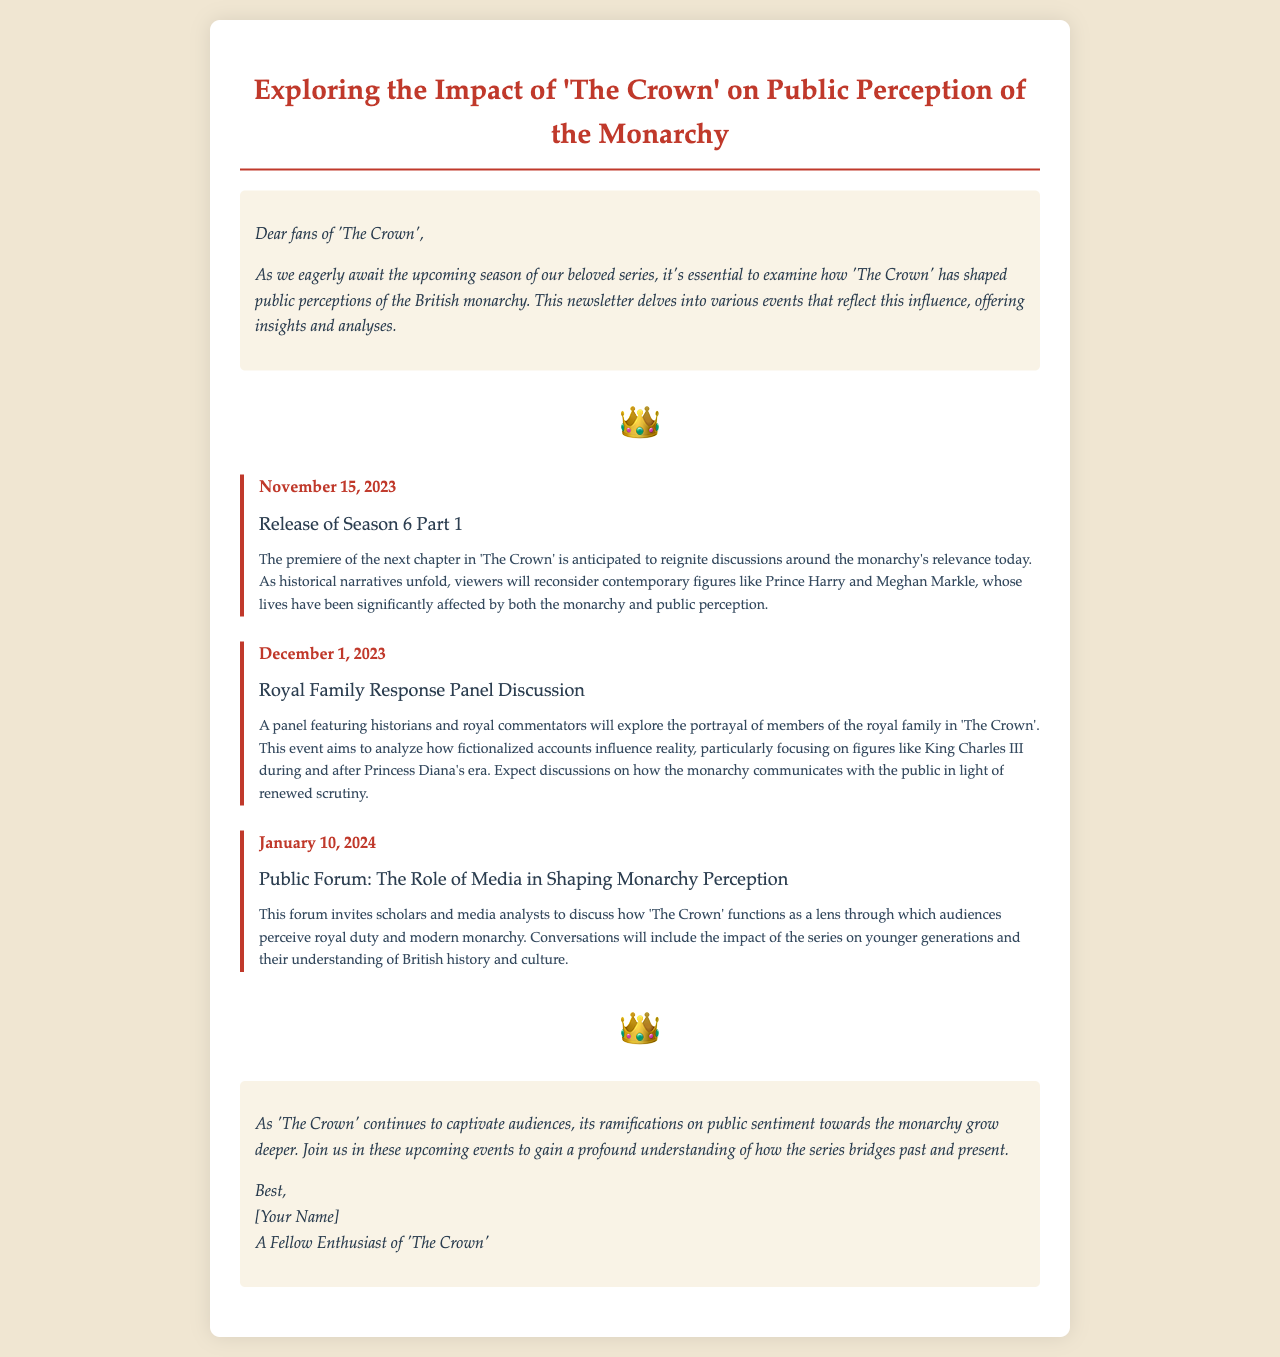What is the title of the newsletter? The title of the newsletter is mentioned prominently at the top of the document.
Answer: Exploring the Impact of 'The Crown' on Public Perception of the Monarchy When is the release date of Season 6 Part 1? The release date is provided in the event section of the newsletter.
Answer: November 15, 2023 What event occurs on December 1, 2023? The event listed for that date is included in the document.
Answer: Royal Family Response Panel Discussion Who is expected to feature in the panel discussion? The document specifies the participants featured in the event.
Answer: Historians and royal commentators What is the focus of the public forum on January 10, 2024? The focus of the forum is described in the event's impact analysis.
Answer: The Role of Media in Shaping Monarchy Perception How does 'The Crown' influence public sentiment toward the monarchy? This insight is drawn from the conclusion of the newsletter.
Answer: Its ramifications grow deeper What type of discussions will occur at the Royal Family Response Panel Discussion? The nature of the discussions is highlighted in the event's analysis.
Answer: Portrayal of members in 'The Crown' Who signed the newsletter? The author of the newsletter is identified in the conclusion.
Answer: [Your Name] 